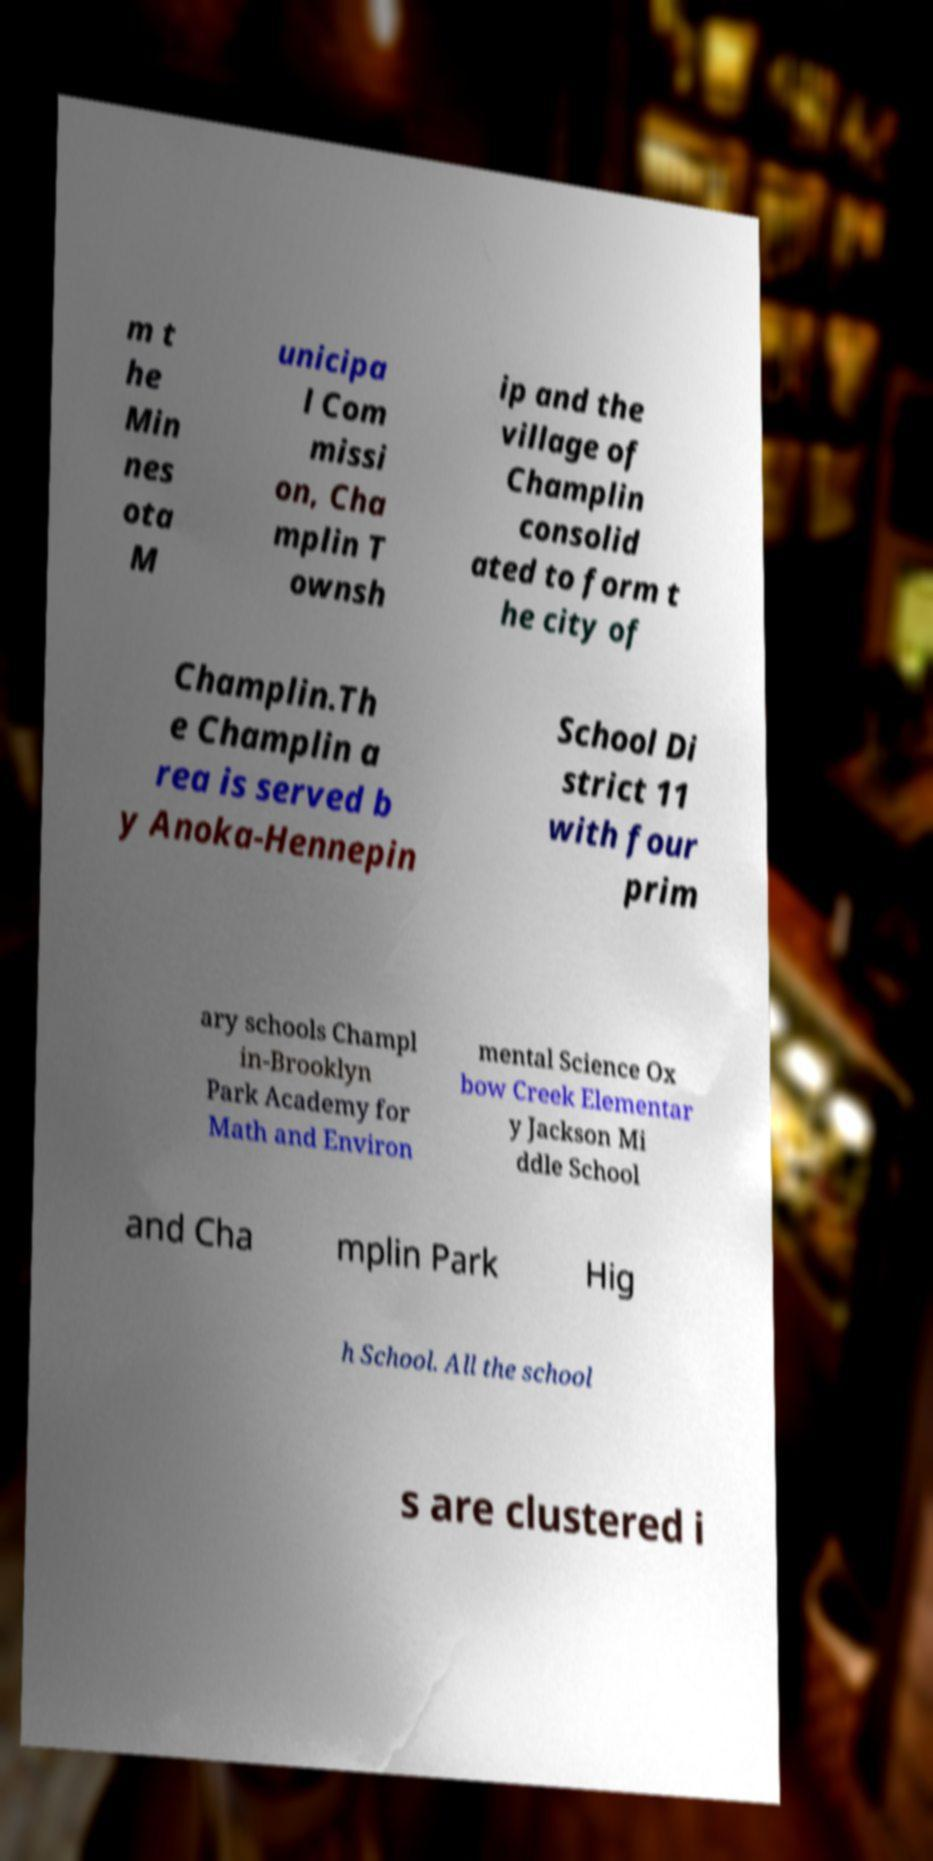Can you accurately transcribe the text from the provided image for me? m t he Min nes ota M unicipa l Com missi on, Cha mplin T ownsh ip and the village of Champlin consolid ated to form t he city of Champlin.Th e Champlin a rea is served b y Anoka-Hennepin School Di strict 11 with four prim ary schools Champl in-Brooklyn Park Academy for Math and Environ mental Science Ox bow Creek Elementar y Jackson Mi ddle School and Cha mplin Park Hig h School. All the school s are clustered i 